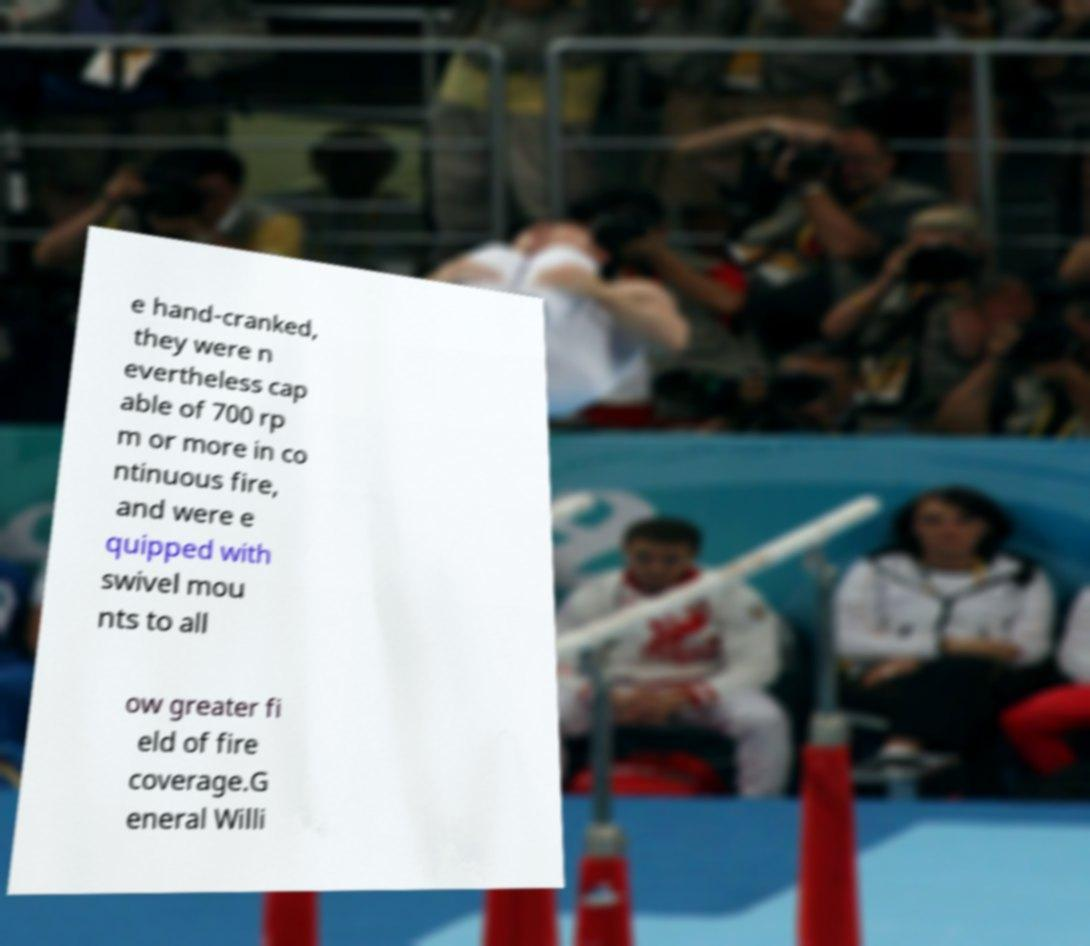What messages or text are displayed in this image? I need them in a readable, typed format. e hand-cranked, they were n evertheless cap able of 700 rp m or more in co ntinuous fire, and were e quipped with swivel mou nts to all ow greater fi eld of fire coverage.G eneral Willi 